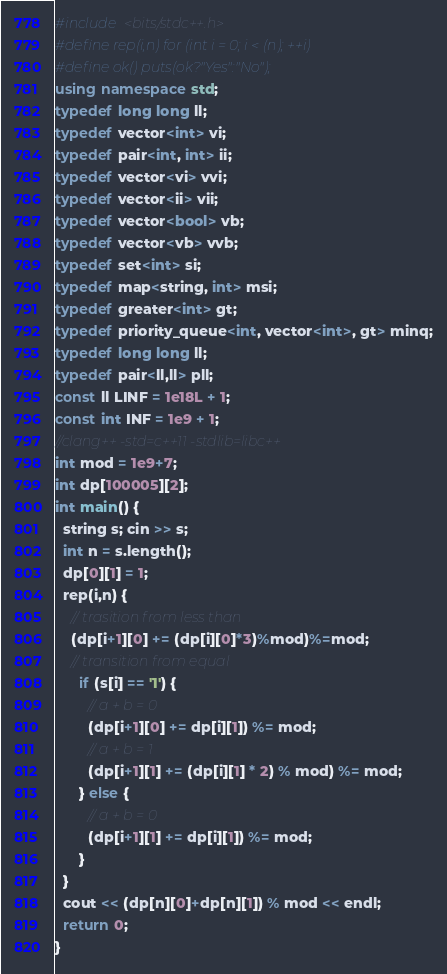Convert code to text. <code><loc_0><loc_0><loc_500><loc_500><_C++_>#include <bits/stdc++.h>
#define rep(i,n) for (int i = 0; i < (n); ++i)
#define ok() puts(ok?"Yes":"No");
using namespace std;
typedef long long ll;
typedef vector<int> vi;
typedef pair<int, int> ii;
typedef vector<vi> vvi;
typedef vector<ii> vii;
typedef vector<bool> vb;
typedef vector<vb> vvb;
typedef set<int> si;
typedef map<string, int> msi;
typedef greater<int> gt;
typedef priority_queue<int, vector<int>, gt> minq;
typedef long long ll;
typedef pair<ll,ll> pll;
const ll LINF = 1e18L + 1;
const int INF = 1e9 + 1;
//clang++ -std=c++11 -stdlib=libc++ 
int mod = 1e9+7;
int dp[100005][2];
int main() {
  string s; cin >> s;
  int n = s.length();
  dp[0][1] = 1;
  rep(i,n) {
    // trasition from less than
    (dp[i+1][0] += (dp[i][0]*3)%mod)%=mod;
    // transition from equal
      if (s[i] == '1') {
        // a + b = 0
        (dp[i+1][0] += dp[i][1]) %= mod; 
        // a + b = 1
        (dp[i+1][1] += (dp[i][1] * 2) % mod) %= mod;
      } else {
        // a + b = 0
        (dp[i+1][1] += dp[i][1]) %= mod;
      }
  }
  cout << (dp[n][0]+dp[n][1]) % mod << endl;
  return 0;
}</code> 